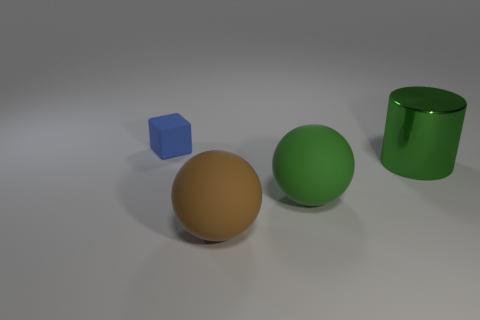Add 4 big rubber things. How many objects exist? 8 Subtract all cylinders. How many objects are left? 3 Add 4 big cyan matte cylinders. How many big cyan matte cylinders exist? 4 Subtract 0 purple cylinders. How many objects are left? 4 Subtract 1 cylinders. How many cylinders are left? 0 Subtract all gray cylinders. Subtract all cyan cubes. How many cylinders are left? 1 Subtract all green cylinders. How many green balls are left? 1 Subtract all small blocks. Subtract all brown matte balls. How many objects are left? 2 Add 4 large green matte things. How many large green matte things are left? 5 